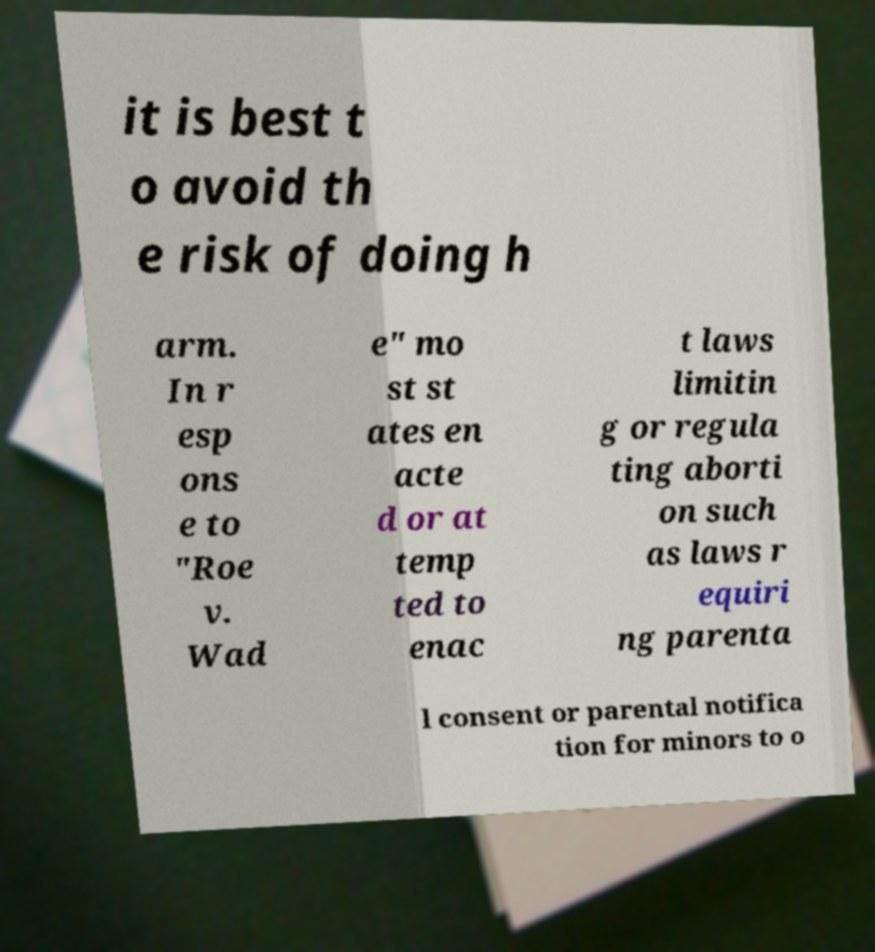For documentation purposes, I need the text within this image transcribed. Could you provide that? it is best t o avoid th e risk of doing h arm. In r esp ons e to "Roe v. Wad e" mo st st ates en acte d or at temp ted to enac t laws limitin g or regula ting aborti on such as laws r equiri ng parenta l consent or parental notifica tion for minors to o 